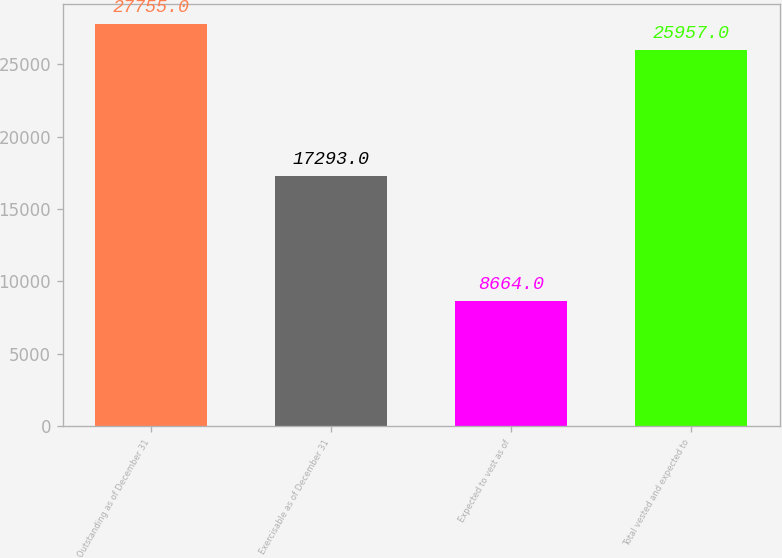<chart> <loc_0><loc_0><loc_500><loc_500><bar_chart><fcel>Outstanding as of December 31<fcel>Exercisable as of December 31<fcel>Expected to vest as of<fcel>Total vested and expected to<nl><fcel>27755<fcel>17293<fcel>8664<fcel>25957<nl></chart> 